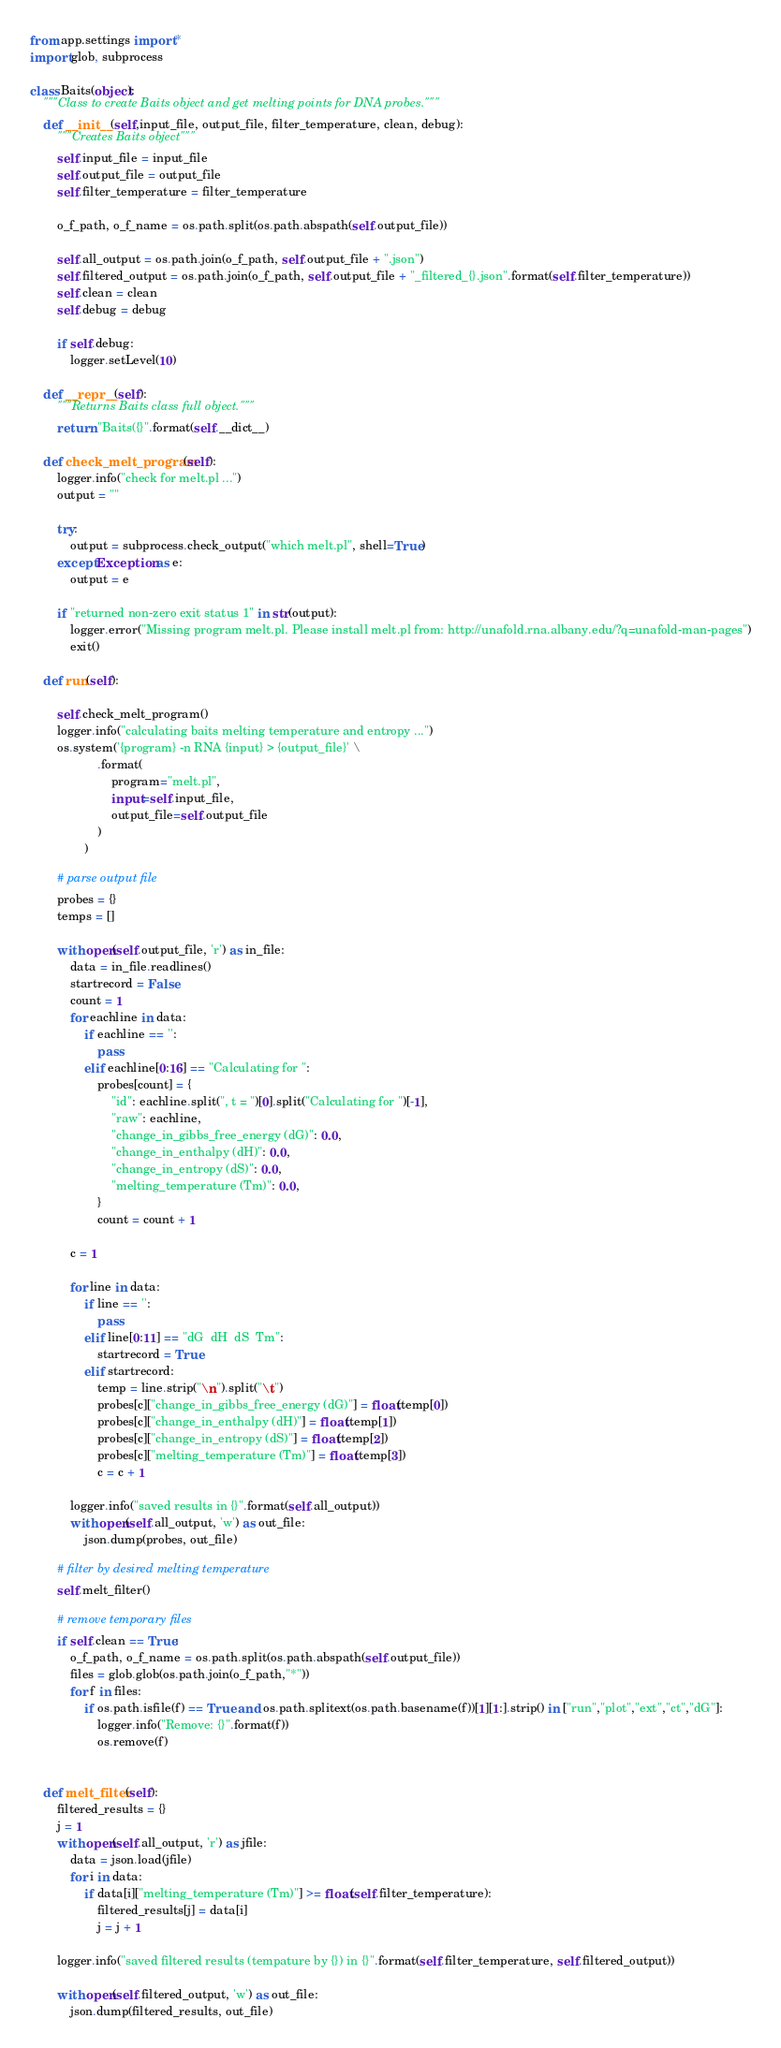Convert code to text. <code><loc_0><loc_0><loc_500><loc_500><_Python_>from app.settings import *
import glob, subprocess

class Baits(object):
	"""Class to create Baits object and get melting points for DNA probes."""
	def __init__(self,input_file, output_file, filter_temperature, clean, debug):
		"""Creates Baits object"""
		self.input_file = input_file
		self.output_file = output_file
		self.filter_temperature = filter_temperature

		o_f_path, o_f_name = os.path.split(os.path.abspath(self.output_file))

		self.all_output = os.path.join(o_f_path, self.output_file + ".json")
		self.filtered_output = os.path.join(o_f_path, self.output_file + "_filtered_{}.json".format(self.filter_temperature))
		self.clean = clean
		self.debug = debug
		
		if self.debug:
			logger.setLevel(10)

	def __repr__(self):
		"""Returns Baits class full object."""
		return "Baits({}".format(self.__dict__)

	def check_melt_program(self):
		logger.info("check for melt.pl ...")
		output = ""

		try:
			output = subprocess.check_output("which melt.pl", shell=True)
		except Exception as e:
			output = e

		if "returned non-zero exit status 1" in str(output):
			logger.error("Missing program melt.pl. Please install melt.pl from: http://unafold.rna.albany.edu/?q=unafold-man-pages")
			exit()

	def run(self):

		self.check_melt_program()
		logger.info("calculating baits melting temperature and entropy ...")
		os.system('{program} -n RNA {input} > {output_file}' \
					.format(
						program="melt.pl", 
						input=self.input_file,
						output_file=self.output_file
					)
				)

		# parse output file
		probes = {}
		temps = []

		with open(self.output_file, 'r') as in_file:
			data = in_file.readlines()
			startrecord = False
			count = 1
			for eachline in data:
				if eachline == '':
					pass
				elif eachline[0:16] == "Calculating for ":
					probes[count] = {
						"id": eachline.split(", t = ")[0].split("Calculating for ")[-1],
						"raw": eachline,  
						"change_in_gibbs_free_energy (dG)": 0.0, 
						"change_in_enthalpy (dH)": 0.0, 
						"change_in_entropy (dS)": 0.0,
						"melting_temperature (Tm)": 0.0,
					}
					count = count + 1

			c = 1

			for line in data:
				if line == '':
					pass
				elif line[0:11] == "dG	dH	dS	Tm":
					startrecord = True
				elif startrecord:
					temp = line.strip("\n").split("\t")
					probes[c]["change_in_gibbs_free_energy (dG)"] = float(temp[0])
					probes[c]["change_in_enthalpy (dH)"] = float(temp[1])
					probes[c]["change_in_entropy (dS)"] = float(temp[2])
					probes[c]["melting_temperature (Tm)"] = float(temp[3])
					c = c + 1

			logger.info("saved results in {}".format(self.all_output))
			with open(self.all_output, 'w') as out_file:
				json.dump(probes, out_file)

		# filter by desired melting temperature
		self.melt_filter()

		# remove temporary files
		if self.clean == True:
			o_f_path, o_f_name = os.path.split(os.path.abspath(self.output_file))
			files = glob.glob(os.path.join(o_f_path,"*"))
			for f in files:
				if os.path.isfile(f) == True and os.path.splitext(os.path.basename(f))[1][1:].strip() in ["run","plot","ext","ct","dG"]:
					logger.info("Remove: {}".format(f))
					os.remove(f)


	def melt_filter(self):
		filtered_results = {}
		j = 1
		with open(self.all_output, 'r') as jfile:
			data = json.load(jfile)
			for i in data:
				if data[i]["melting_temperature (Tm)"] >= float(self.filter_temperature):
					filtered_results[j] = data[i]
					j = j + 1

		logger.info("saved filtered results (tempature by {}) in {}".format(self.filter_temperature, self.filtered_output))

		with open(self.filtered_output, 'w') as out_file:
			json.dump(filtered_results, out_file)




</code> 